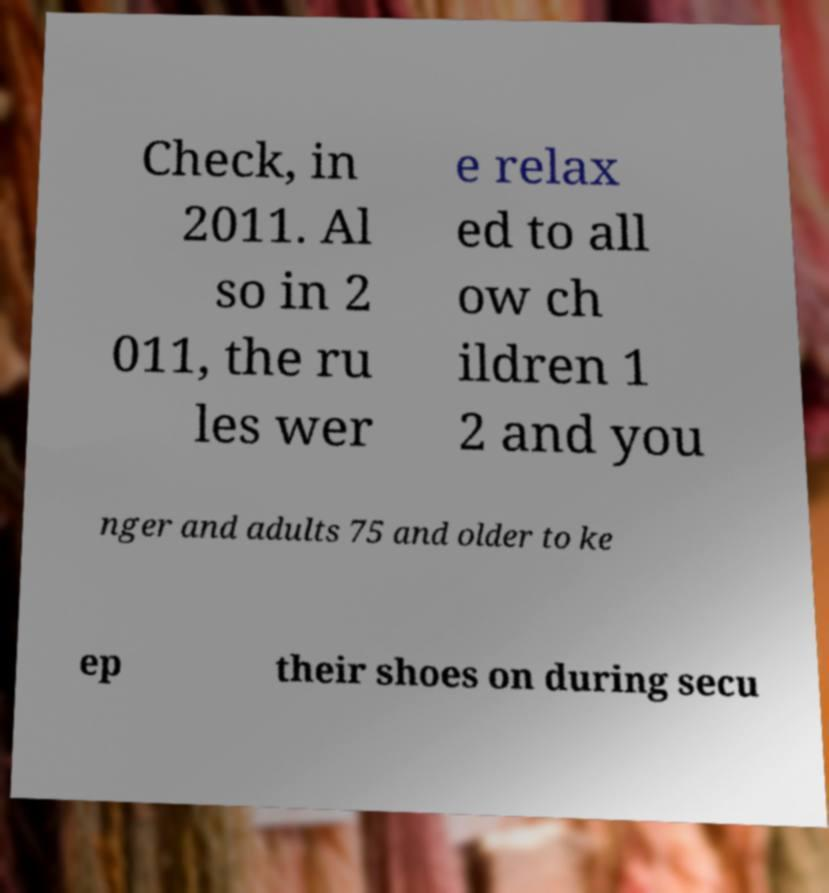Can you accurately transcribe the text from the provided image for me? Check, in 2011. Al so in 2 011, the ru les wer e relax ed to all ow ch ildren 1 2 and you nger and adults 75 and older to ke ep their shoes on during secu 